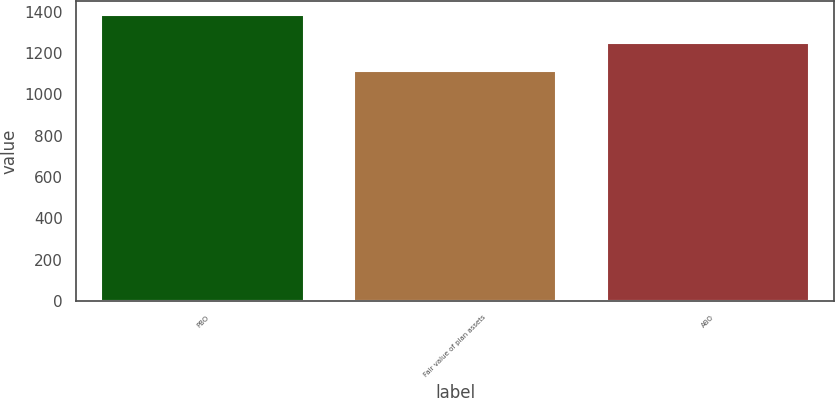<chart> <loc_0><loc_0><loc_500><loc_500><bar_chart><fcel>PBO<fcel>Fair value of plan assets<fcel>ABO<nl><fcel>1383.3<fcel>1113.2<fcel>1249.1<nl></chart> 